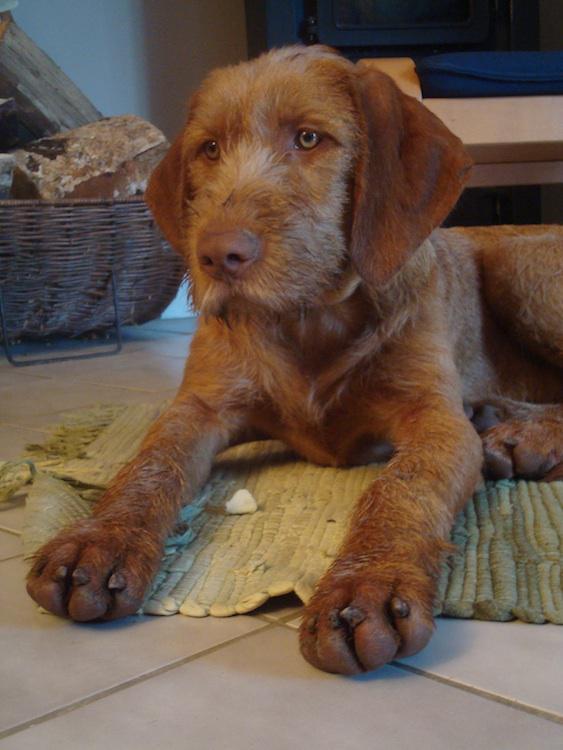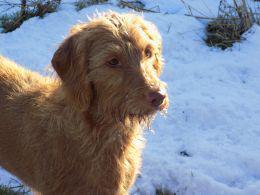The first image is the image on the left, the second image is the image on the right. Considering the images on both sides, is "There is a total of two dogs with one sitting and one standing." valid? Answer yes or no. No. The first image is the image on the left, the second image is the image on the right. Assess this claim about the two images: "In one image, a dog is standing with one of its paws lifted up off the ground.". Correct or not? Answer yes or no. No. 